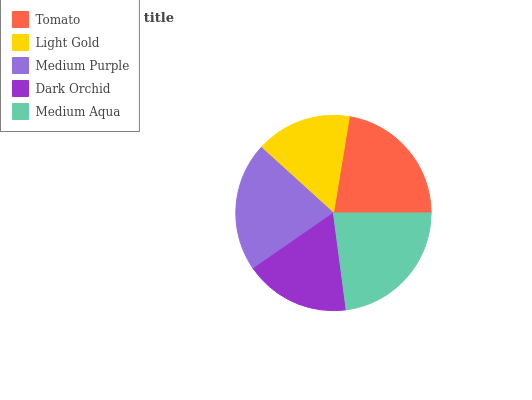Is Light Gold the minimum?
Answer yes or no. Yes. Is Medium Aqua the maximum?
Answer yes or no. Yes. Is Medium Purple the minimum?
Answer yes or no. No. Is Medium Purple the maximum?
Answer yes or no. No. Is Medium Purple greater than Light Gold?
Answer yes or no. Yes. Is Light Gold less than Medium Purple?
Answer yes or no. Yes. Is Light Gold greater than Medium Purple?
Answer yes or no. No. Is Medium Purple less than Light Gold?
Answer yes or no. No. Is Medium Purple the high median?
Answer yes or no. Yes. Is Medium Purple the low median?
Answer yes or no. Yes. Is Medium Aqua the high median?
Answer yes or no. No. Is Dark Orchid the low median?
Answer yes or no. No. 